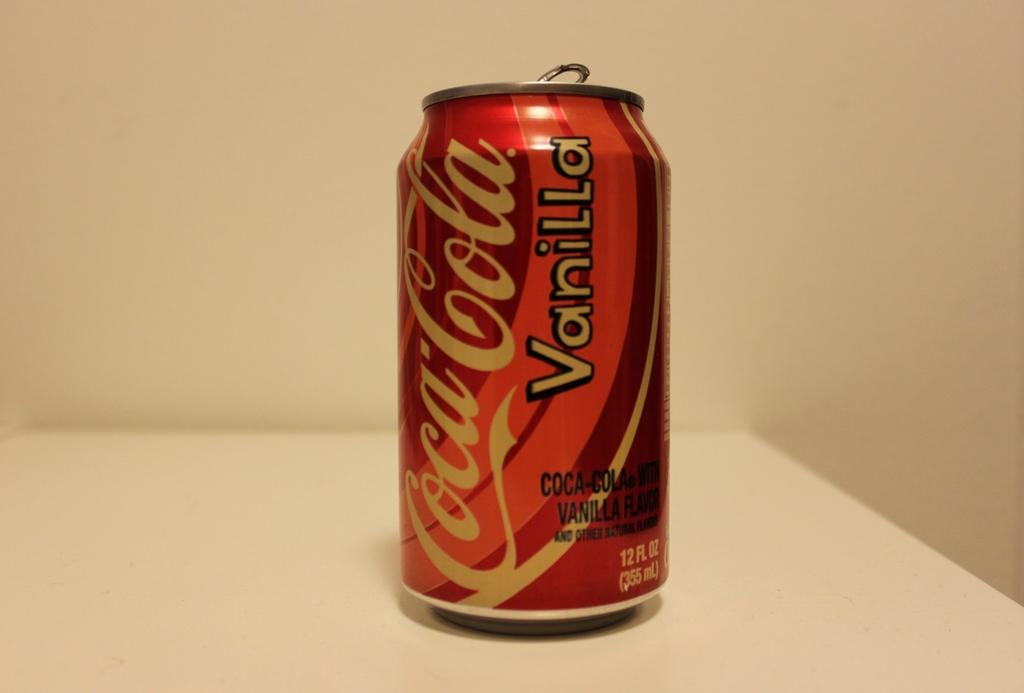<image>
Present a compact description of the photo's key features. A lone can of CocaCola Vanilla on a table. 